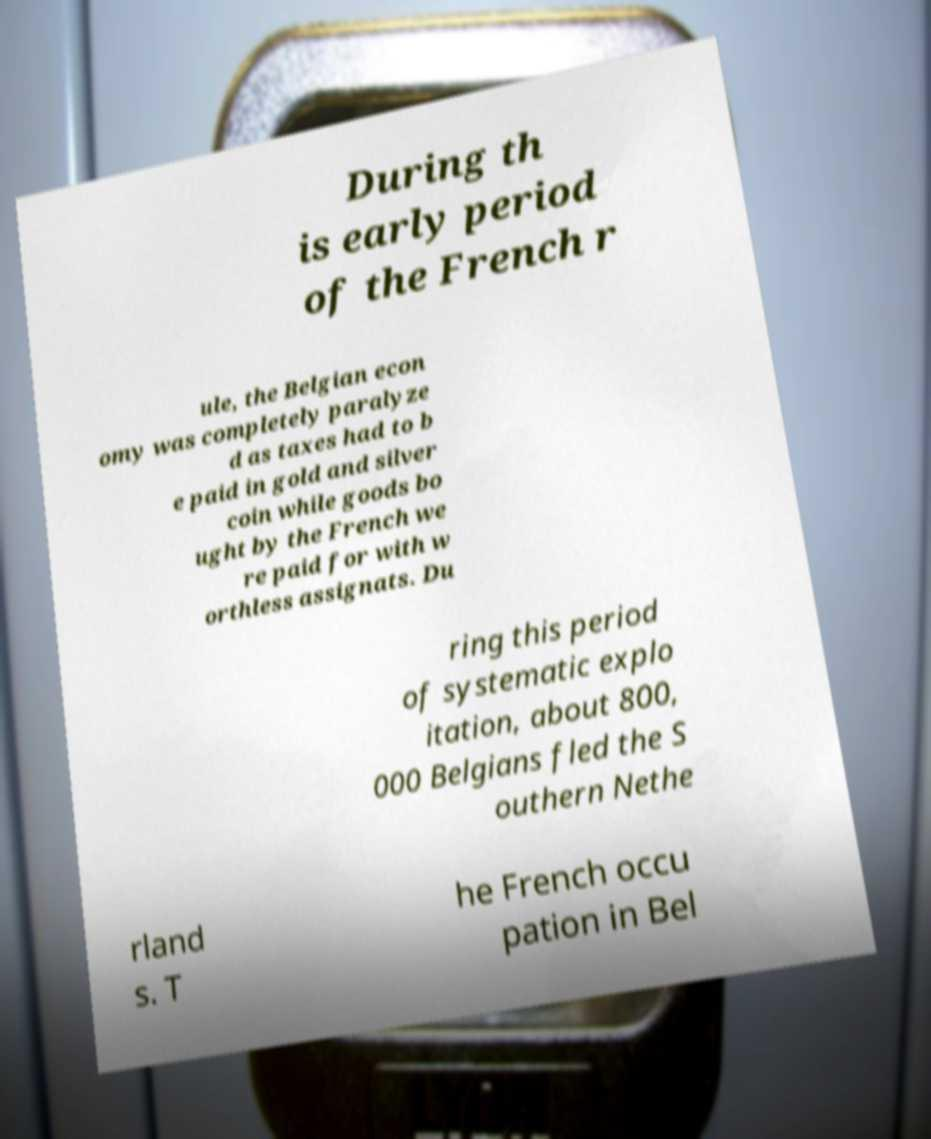What messages or text are displayed in this image? I need them in a readable, typed format. During th is early period of the French r ule, the Belgian econ omy was completely paralyze d as taxes had to b e paid in gold and silver coin while goods bo ught by the French we re paid for with w orthless assignats. Du ring this period of systematic explo itation, about 800, 000 Belgians fled the S outhern Nethe rland s. T he French occu pation in Bel 